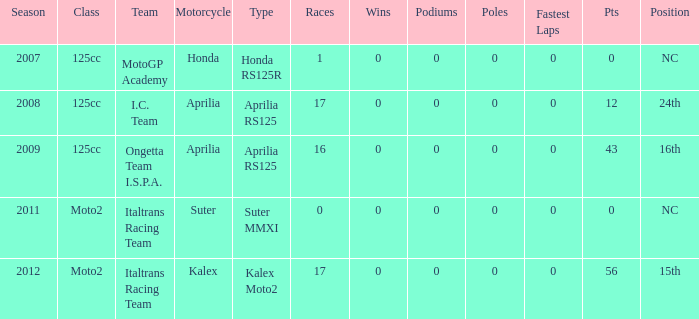Write the full table. {'header': ['Season', 'Class', 'Team', 'Motorcycle', 'Type', 'Races', 'Wins', 'Podiums', 'Poles', 'Fastest Laps', 'Pts', 'Position'], 'rows': [['2007', '125cc', 'MotoGP Academy', 'Honda', 'Honda RS125R', '1', '0', '0', '0', '0', '0', 'NC'], ['2008', '125cc', 'I.C. Team', 'Aprilia', 'Aprilia RS125', '17', '0', '0', '0', '0', '12', '24th'], ['2009', '125cc', 'Ongetta Team I.S.P.A.', 'Aprilia', 'Aprilia RS125', '16', '0', '0', '0', '0', '43', '16th'], ['2011', 'Moto2', 'Italtrans Racing Team', 'Suter', 'Suter MMXI', '0', '0', '0', '0', '0', '0', 'NC'], ['2012', 'Moto2', 'Italtrans Racing Team', 'Kalex', 'Kalex Moto2', '17', '0', '0', '0', '0', '56', '15th']]} What's the number of poles in the season where the team had a Kalex motorcycle? 0.0. 